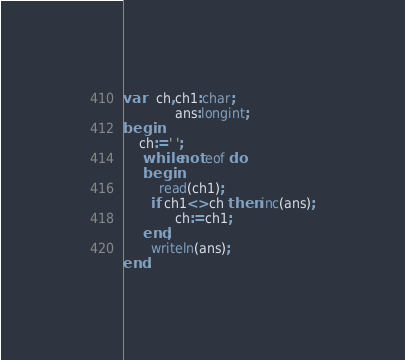Convert code to text. <code><loc_0><loc_0><loc_500><loc_500><_Pascal_>var   ch,ch1:char;
             ans:longint;
begin
    ch:=' ';
     while not eof do
     begin
         read(ch1);
       if ch1<>ch then inc(ans);
             ch:=ch1;
     end;
       writeln(ans);
end.</code> 